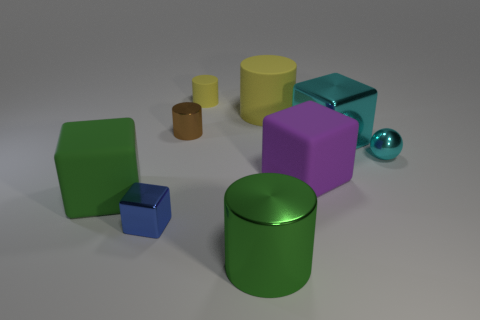There is a large cylinder that is the same color as the small rubber thing; what is it made of?
Keep it short and to the point. Rubber. Is the sphere the same color as the large shiny block?
Your response must be concise. Yes. How many cubes are the same material as the purple thing?
Your answer should be very brief. 1. What number of objects are metal blocks that are to the left of the big yellow cylinder or blue shiny objects that are on the left side of the large metal cylinder?
Your answer should be very brief. 1. Is the number of yellow rubber cylinders behind the purple object greater than the number of green cylinders behind the green cylinder?
Your response must be concise. Yes. There is a metallic cylinder in front of the tiny cyan sphere; what is its color?
Make the answer very short. Green. Is there another shiny thing of the same shape as the tiny brown thing?
Your answer should be very brief. Yes. How many gray objects are big cubes or small metal spheres?
Your response must be concise. 0. Is there a metal cylinder of the same size as the blue object?
Provide a short and direct response. Yes. How many green objects are there?
Give a very brief answer. 2. 